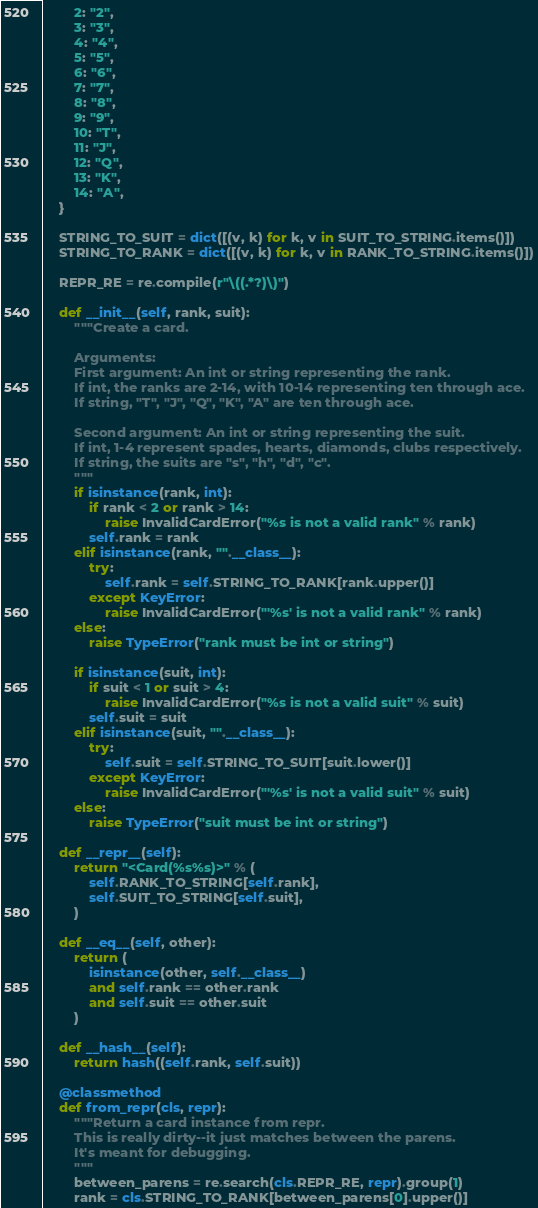Convert code to text. <code><loc_0><loc_0><loc_500><loc_500><_Python_>        2: "2",
        3: "3",
        4: "4",
        5: "5",
        6: "6",
        7: "7",
        8: "8",
        9: "9",
        10: "T",
        11: "J",
        12: "Q",
        13: "K",
        14: "A",
    }

    STRING_TO_SUIT = dict([(v, k) for k, v in SUIT_TO_STRING.items()])
    STRING_TO_RANK = dict([(v, k) for k, v in RANK_TO_STRING.items()])

    REPR_RE = re.compile(r"\((.*?)\)")

    def __init__(self, rank, suit):
        """Create a card.

        Arguments:
        First argument: An int or string representing the rank.
        If int, the ranks are 2-14, with 10-14 representing ten through ace.
        If string, "T", "J", "Q", "K", "A" are ten through ace.

        Second argument: An int or string representing the suit.
        If int, 1-4 represent spades, hearts, diamonds, clubs respectively.
        If string, the suits are "s", "h", "d", "c".
        """
        if isinstance(rank, int):
            if rank < 2 or rank > 14:
                raise InvalidCardError("%s is not a valid rank" % rank)
            self.rank = rank
        elif isinstance(rank, "".__class__):
            try:
                self.rank = self.STRING_TO_RANK[rank.upper()]
            except KeyError:
                raise InvalidCardError("'%s' is not a valid rank" % rank)
        else:
            raise TypeError("rank must be int or string")

        if isinstance(suit, int):
            if suit < 1 or suit > 4:
                raise InvalidCardError("%s is not a valid suit" % suit)
            self.suit = suit
        elif isinstance(suit, "".__class__):
            try:
                self.suit = self.STRING_TO_SUIT[suit.lower()]
            except KeyError:
                raise InvalidCardError("'%s' is not a valid suit" % suit)
        else:
            raise TypeError("suit must be int or string")

    def __repr__(self):
        return "<Card(%s%s)>" % (
            self.RANK_TO_STRING[self.rank],
            self.SUIT_TO_STRING[self.suit],
        )

    def __eq__(self, other):
        return (
            isinstance(other, self.__class__)
            and self.rank == other.rank
            and self.suit == other.suit
        )

    def __hash__(self):
        return hash((self.rank, self.suit))

    @classmethod
    def from_repr(cls, repr):
        """Return a card instance from repr.
        This is really dirty--it just matches between the parens.
        It's meant for debugging.
        """
        between_parens = re.search(cls.REPR_RE, repr).group(1)
        rank = cls.STRING_TO_RANK[between_parens[0].upper()]</code> 